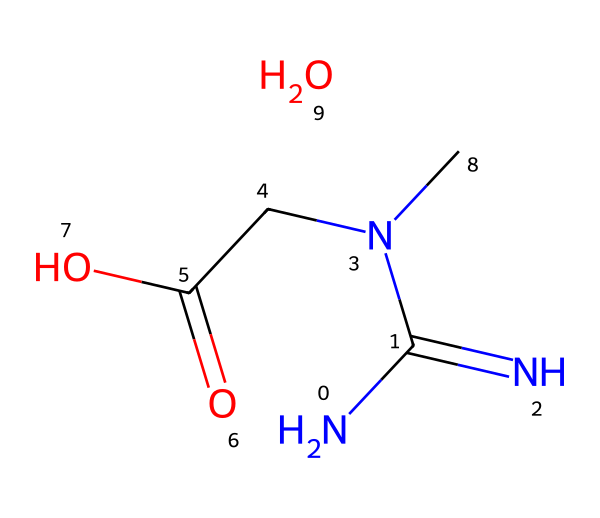What is the molecular formula of creatine monohydrate? To find the molecular formula, we count the atoms from the SMILES representation. The components in the SMILES include carbon (C), hydrogen (H), nitrogen (N), and oxygen (O). By tallying, we find there are 4 carbons, 9 hydrogens, 3 nitrogens, and 2 oxygens which together give C4H9N3O2.
Answer: C4H9N3O2 How many nitrogen atoms are present in the structure? From the SMILES, we can see there are three nitrogen atoms (N) represented, indicated explicitly in the structure.
Answer: 3 What type of functional groups are present in creatine monohydrate? Looking at the chemical structure, we can identify a carboxylic acid group (–COOH) and an amine group (–NH). These are typical functional groups in organic compounds, especially relevant in creatine.
Answer: carboxylic acid and amine What is the primary use of creatine monohydrate? Creatine monohydrate is commonly used as a supplement to improve athletic performance, especially in high-intensity sports. This is supported by its structure promoting energy production in muscles.
Answer: athletic performance Is creatine monohydrate a natural or synthetic substance? Creatine monohydrate is naturally found in the body, as well as in meats and fish, but it is also produced synthetically for supplements.
Answer: both What does the monohydrate part of creatine monohydrate signify? The term monohydrate refers to the inclusion of one molecule of water (H2O) associated with each molecule of creatine, indicating its hydrated form. This can be reflected in the structure where water is indicated at the end of the SMILES representation.
Answer: one molecule of water 